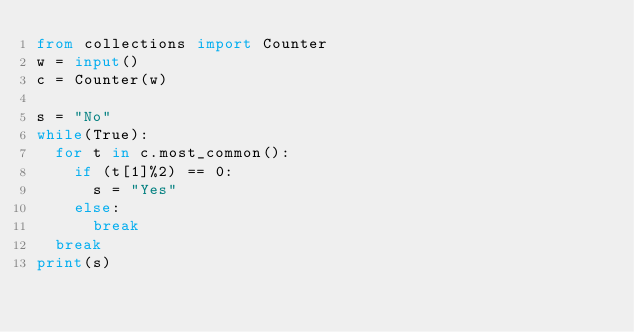Convert code to text. <code><loc_0><loc_0><loc_500><loc_500><_Python_>from collections import Counter
w = input()
c = Counter(w)

s = "No"
while(True):
  for t in c.most_common():
    if (t[1]%2) == 0:
      s = "Yes"
    else:
      break
  break
print(s)</code> 